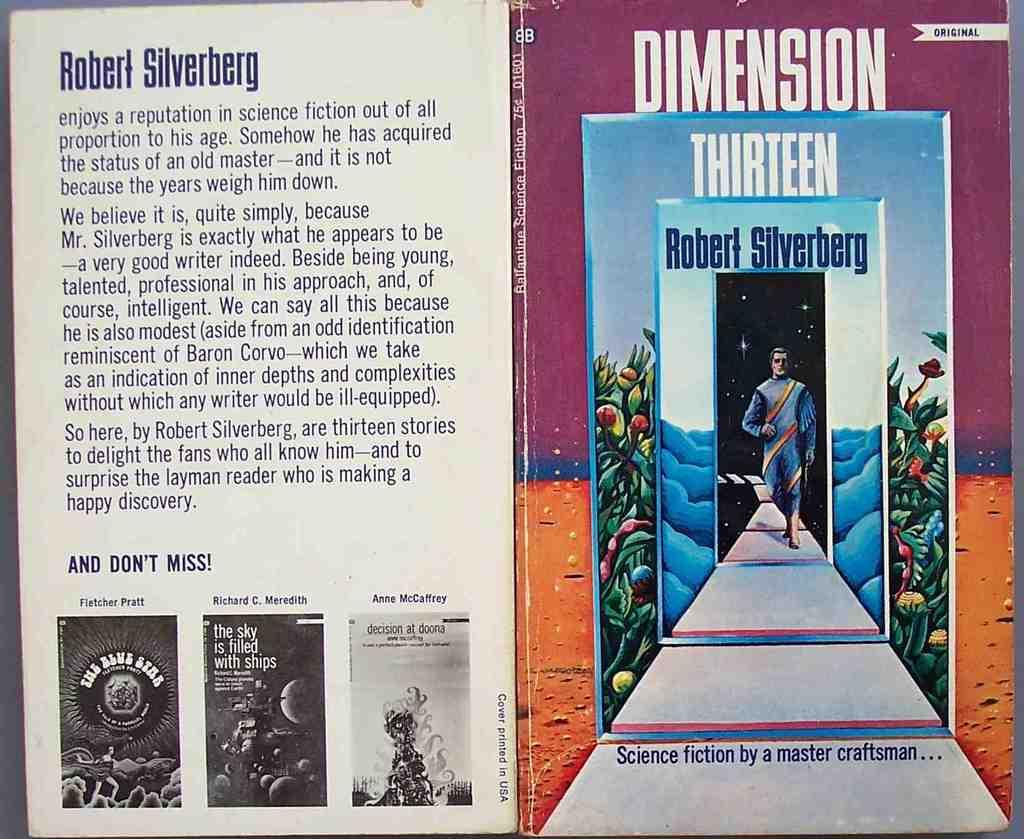What is the name of this book?
Provide a short and direct response. Dimension thirteen. 